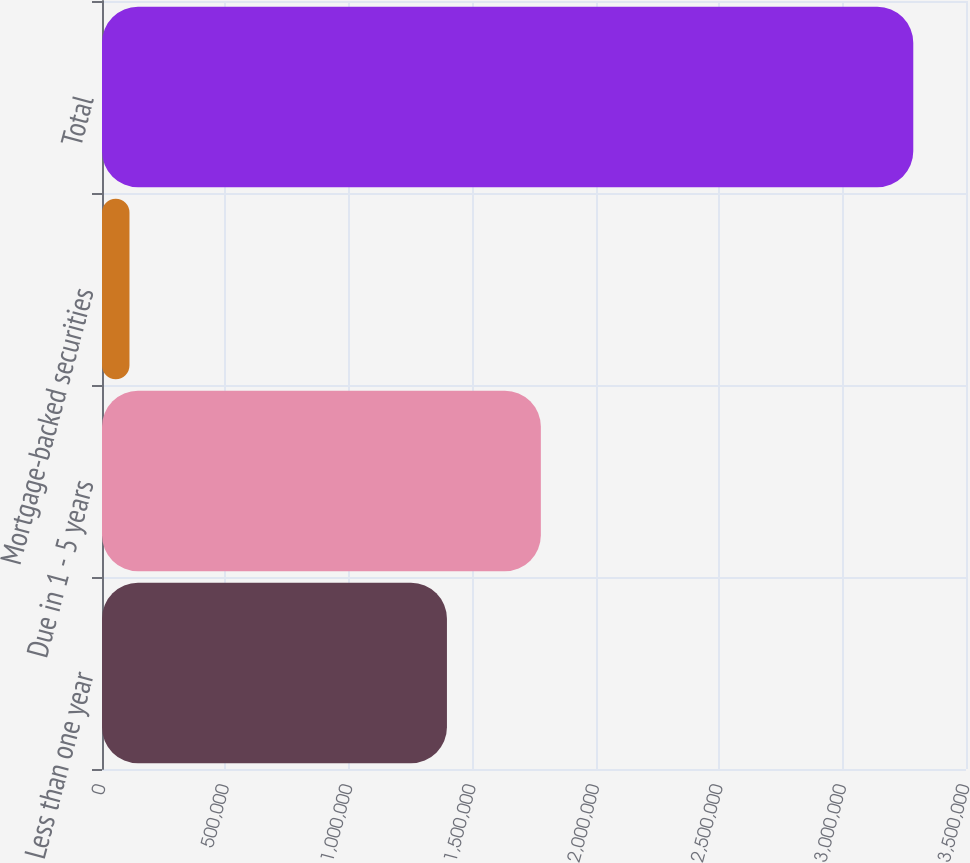Convert chart to OTSL. <chart><loc_0><loc_0><loc_500><loc_500><bar_chart><fcel>Less than one year<fcel>Due in 1 - 5 years<fcel>Mortgage-backed securities<fcel>Total<nl><fcel>1.39735e+06<fcel>1.77778e+06<fcel>111301<fcel>3.28644e+06<nl></chart> 